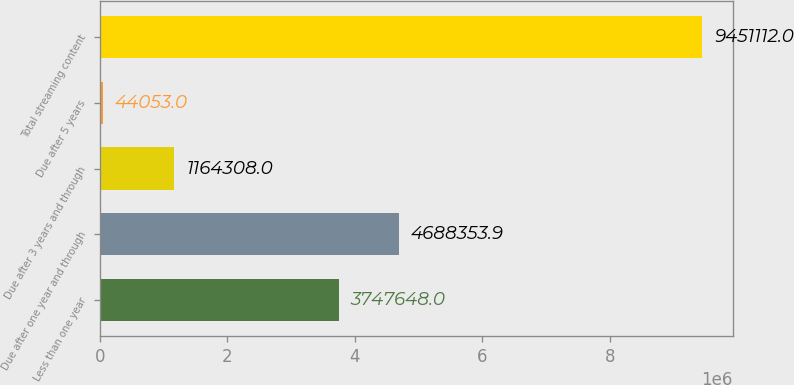<chart> <loc_0><loc_0><loc_500><loc_500><bar_chart><fcel>Less than one year<fcel>Due after one year and through<fcel>Due after 3 years and through<fcel>Due after 5 years<fcel>Total streaming content<nl><fcel>3.74765e+06<fcel>4.68835e+06<fcel>1.16431e+06<fcel>44053<fcel>9.45111e+06<nl></chart> 